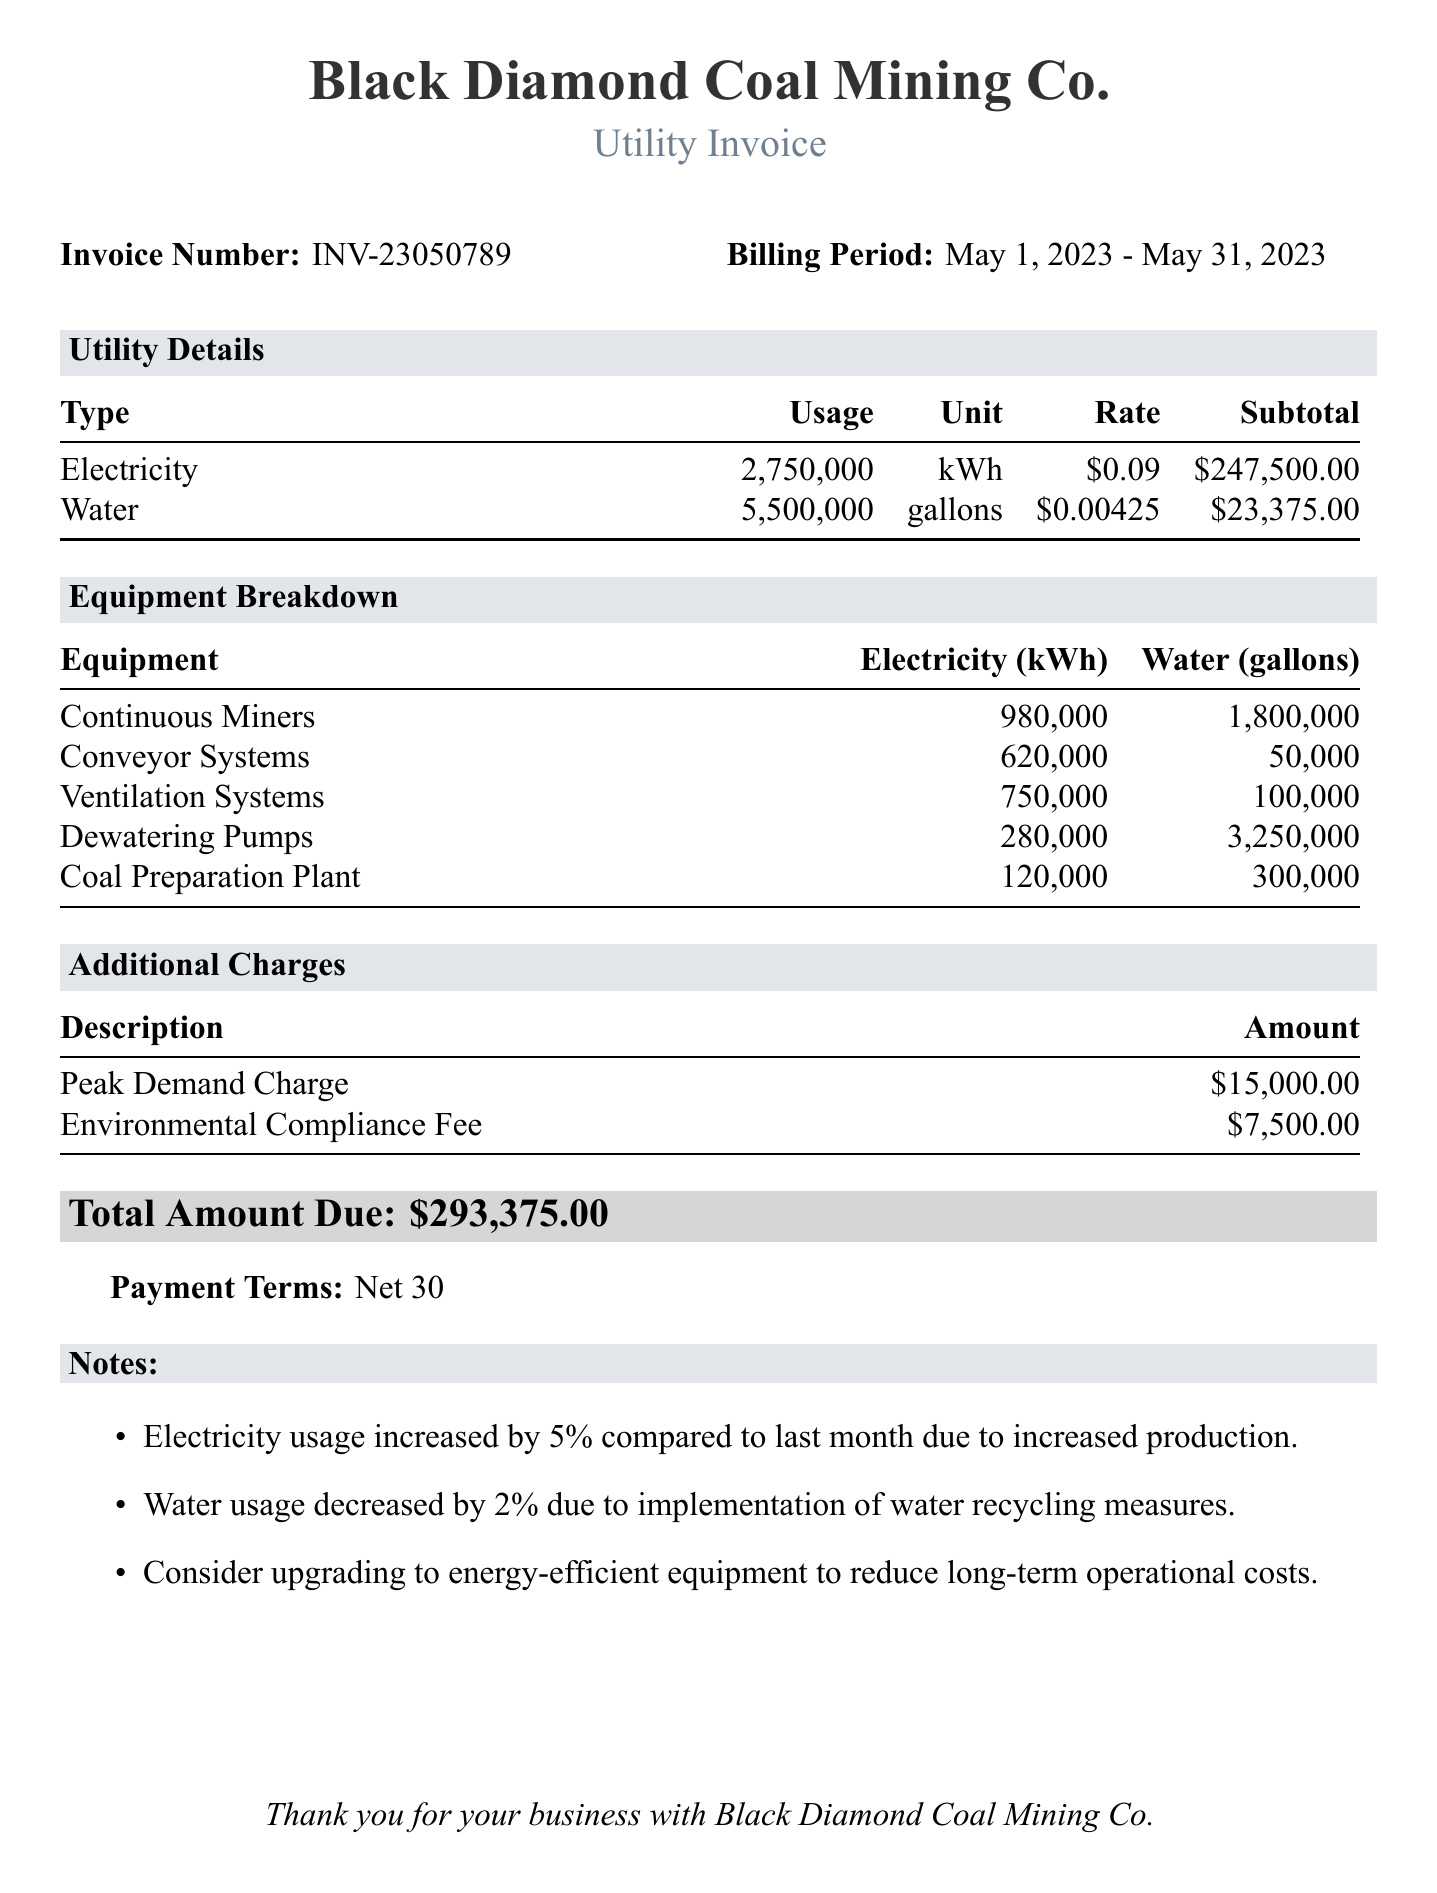What is the invoice number? The invoice number is explicitly stated in the document, listed under Invoice Number.
Answer: INV-23050789 What is the billing period? The billing period is provided in the document, indicating the timeframe for the charges.
Answer: May 1, 2023 - May 31, 2023 What was the subtotal for electricity usage? The subtotal for electricity usage is detailed in the utility details section of the document.
Answer: $247,500.00 How much water was used in gallons? The total water usage is specified in the utility details section.
Answer: 5,500,000 gallons What is the total amount due? The document highlights the total amount due at the end, summarizing all charges.
Answer: $293,375.00 What percentage increase in electricity usage is noted compared to last month? The document notes the percentage increase of electricity usage compared to the previous month.
Answer: 5% What additional charge is for Environmental Compliance Fee? The document lists the details of additional charges specifically mentioning this fee.
Answer: $7,500.00 Which equipment used the most electricity? The equipment breakdown section details the electricity consumption for each type, indicating usage.
Answer: Continuous Miners What does "Net 30" refer to in the document? The payment terms section indicates the timeframe for payment after receiving the invoice.
Answer: Payment terms What recommendation is given for reducing long-term operational costs? Notes in the document suggest considering a specific measure for cost reduction.
Answer: Upgrading to energy-efficient equipment 